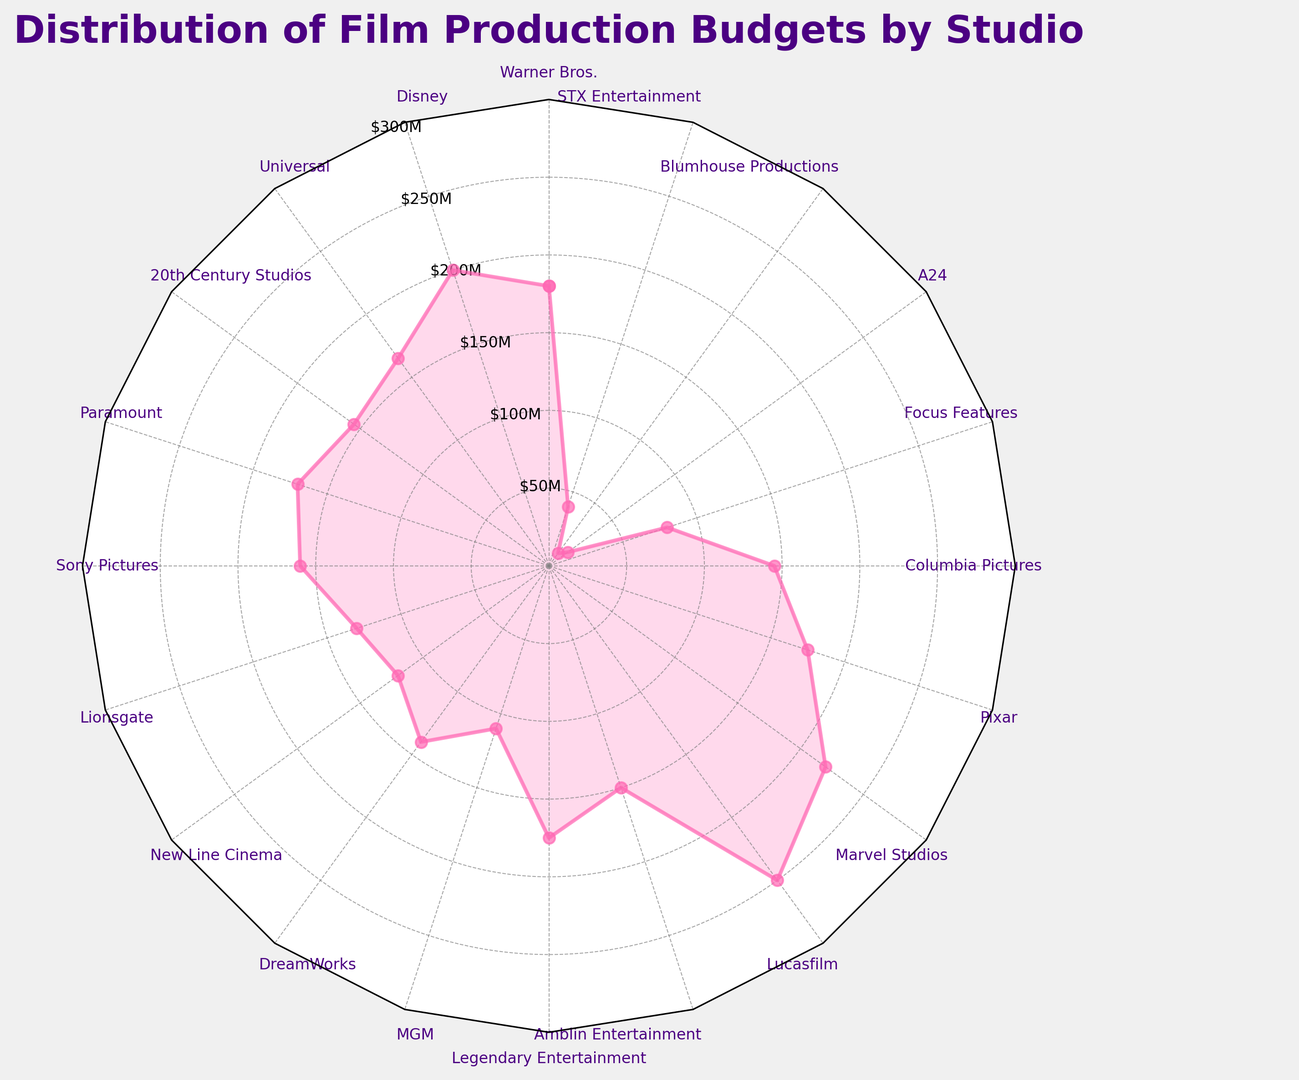What studio has the highest average production budget? The radar chart visually presents budget distribution with each studio marked around the chart, and their corresponding budget values shown as distances from the center. The studio with the longest distance from the center represents the highest budget.
Answer: Lucasfilm Which studio has the lowest average production budget? The point closest to the center of the radar chart indicates the lowest budget. By observing the closest point, we see that it is associated with Blumhouse Productions.
Answer: Blumhouse Productions How much is the difference in average budget between Disney and Paramount? Disney's average budget is shown as 200 million USD and Paramount's as 170 million USD on the radar chart. The difference can be calculated by subtracting Paramount's budget from Disney's budget. \( 200 - 170 = 30 \)
Answer: 30 million USD Is 20th Century Studios' average budget higher or lower than Universal's? To compare, look at the distances from the center for both studios. 20th Century Studios is marked at 155 million USD and Universal at 165 million USD. The value for Universal is farther from the center, indicating a higher budget.
Answer: Lower Which studios have an average budget greater than 175 million USD? By identifying the points on the radar chart that are beyond the 175 million USD line, we can see that Lucasfilm, Marvel Studios, and Disney have budgets greater than 175 million USD.
Answer: Lucasfilm, Marvel Studios, Disney What is the average budget of Warner Bros., Paramount, and Sony Pictures combined? Warner Bros.' budget is 180 million USD, Paramount's is 170 million USD, and Sony Pictures' is 160 million USD. Summing these values and dividing by 3 gives \( (180 + 170 + 160)/3 = 510/3 = 170 \) million USD.
Answer: 170 million USD Between MGM and DreamWorks, which studio has a lower average budget and by how much? MGM's budget is 110 million USD, and DreamWorks’ budget is 140 million USD. Subtract MGM’s budget from DreamWorks’ budget to find the difference. \( 140 - 110 = 30 \) million USD.
Answer: MGM by 30 million USD Are there any studios with an average budget between 100 million and 150 million USD? By checking the range between the 100 million and 150 million USD lines on the radar chart, we verify that MGM, New Line Cinema, DreamWorks, Columbia Pictures, and Lionsgate fall within this range.
Answer: MGM, New Line Cinema, DreamWorks, Columbia Pictures, Lionsgate Which studio has a budget closest to the average of all studios listed? First, calculate the overall average. Sum all studios' average budgets: \( 180 + 200 + 165 + 155 + 170 + 160 + 130 + 120 + 140 + 110 + 175 + 150 + 250 + 220 + 175 + 145 + 80 + 15 + 10 + 40 = 2950 \). Divide by the number of studios (20). The overall average is \( 2950/20 = 147.5 \) million USD. Columbia Pictures with 145 million USD is closest to this average.
Answer: Columbia Pictures 